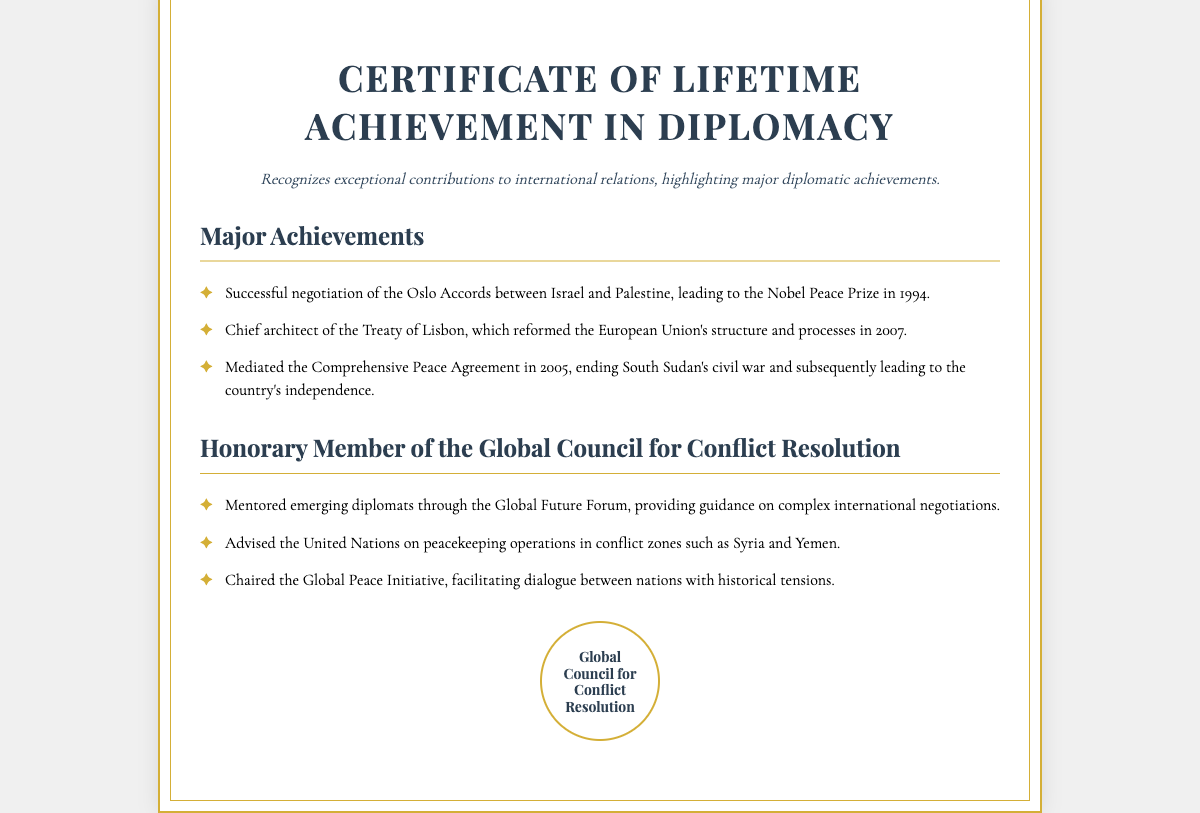What is the title of the certificate? The title of the certificate is highlighted prominently at the top of the document.
Answer: Certificate of Lifetime Achievement in Diplomacy What award is associated with the negotiation of the Oslo Accords? The document notes that the successful negotiation of the Oslo Accords led to a specific honor in 1994.
Answer: Nobel Peace Prize In what year was the Treaty of Lisbon signed? The document explicitly mentions the year when the Treaty of Lisbon was reformed.
Answer: 2007 What is the primary focus of the Honorary Member section? The document outlines the recipient's involvement in mentoring emerging diplomats and other activities related to peace initiatives.
Answer: Mentoring emerging diplomats Which agreement ended South Sudan's civil war? The document specifies a comprehensive peace agreement that concluded the civil war in South Sudan.
Answer: Comprehensive Peace Agreement How many major achievements are listed in the document? The section detailing major achievements provides a specific count of the listed items.
Answer: Three What type of forum did the recipient maintain a mentorship role in? The document mentions a particular forum related to future diplomacy and mentorship.
Answer: Global Future Forum What does the seal in the document represent? The seal displays the title associated with the council to which the recipient belongs, indicating its prestige.
Answer: Global Council for Conflict Resolution 